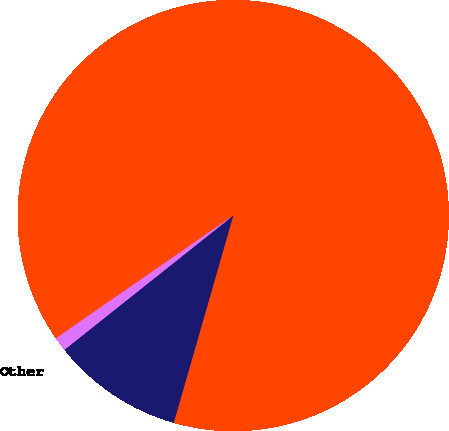Convert chart to OTSL. <chart><loc_0><loc_0><loc_500><loc_500><pie_chart><fcel>Multiple purpose<fcel>Switching<fcel>Other<nl><fcel>89.09%<fcel>9.86%<fcel>1.05%<nl></chart> 